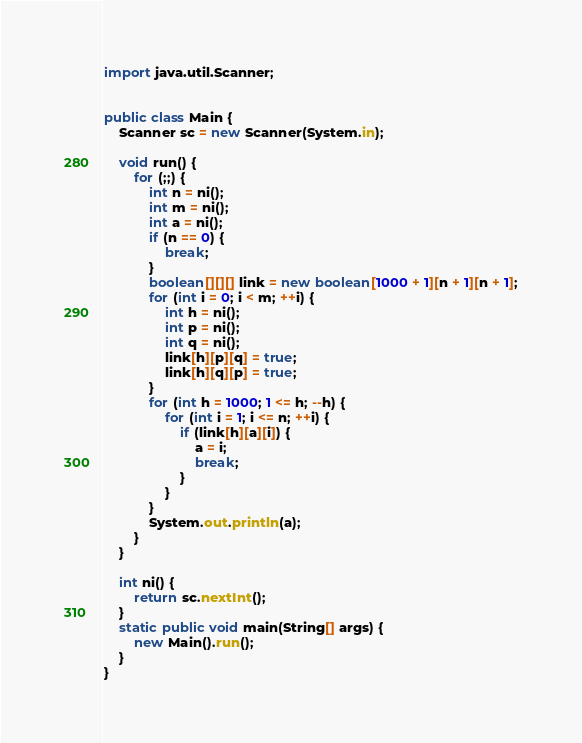<code> <loc_0><loc_0><loc_500><loc_500><_Java_>import java.util.Scanner;


public class Main {
    Scanner sc = new Scanner(System.in);

    void run() {
        for (;;) {
            int n = ni();
            int m = ni();
            int a = ni();
            if (n == 0) {
                break;
            }
            boolean[][][] link = new boolean[1000 + 1][n + 1][n + 1];
            for (int i = 0; i < m; ++i) {
                int h = ni();
                int p = ni();
                int q = ni();
                link[h][p][q] = true;
                link[h][q][p] = true;
            }
            for (int h = 1000; 1 <= h; --h) {
                for (int i = 1; i <= n; ++i) {
                    if (link[h][a][i]) {
                        a = i;
                        break;
                    }
                }
            }
            System.out.println(a);
        }
    }

    int ni() {
        return sc.nextInt();
    }
    static public void main(String[] args) {
        new Main().run();
    }
}</code> 